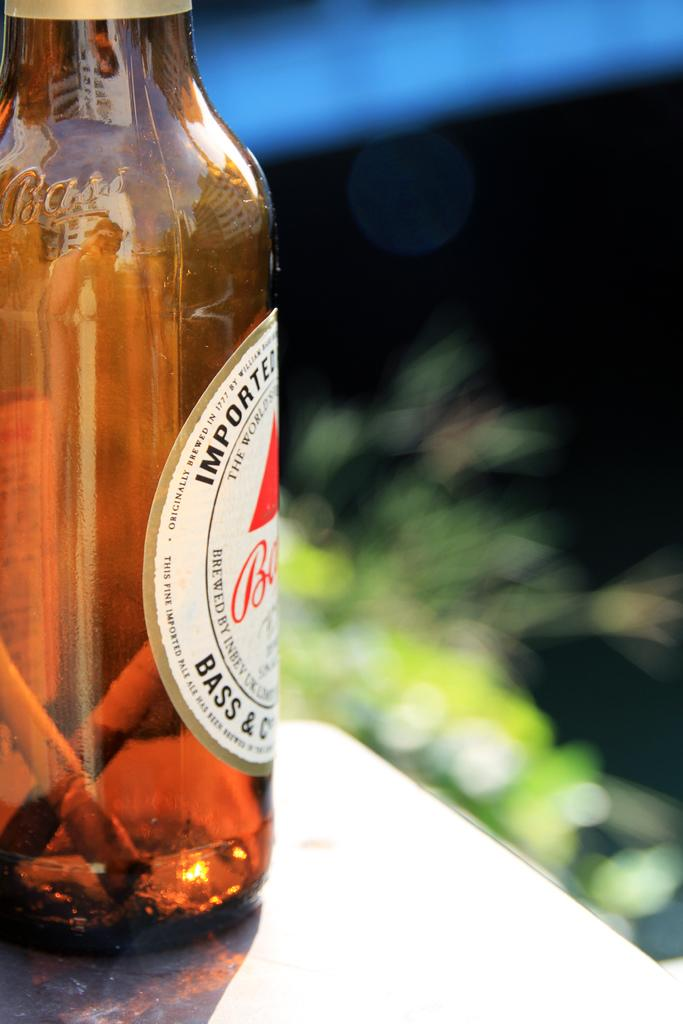What is present in the image? There is a bottle in the image. What can be found inside the bottle? There are objects inside the bottle. Is there any additional information about the bottle? The bottle has a sticker. Where is the bottle located? The bottle is placed on a table. How many cars are visible inside the bottle? There are no cars visible inside the bottle; it contains objects, but no cars are mentioned. 